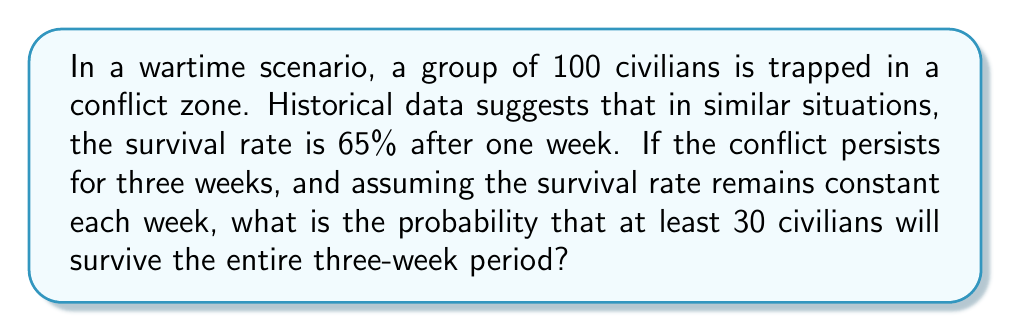Show me your answer to this math problem. Let's approach this problem step-by-step:

1) First, we need to calculate the probability of survival for the entire three-week period. If the weekly survival rate is 65%, then:

   $P(\text{survival for 3 weeks}) = 0.65 \times 0.65 \times 0.65 = 0.65^3 \approx 0.2746$

2) Now, we can consider this as a binomial probability problem. We want to find the probability of at least 30 successes (survivors) out of 100 trials, where the probability of success on each trial is 0.2746.

3) The probability of at least 30 survivors is equal to 1 minus the probability of 29 or fewer survivors:

   $P(X \geq 30) = 1 - P(X \leq 29)$

   where X is the number of survivors.

4) We can calculate this using the cumulative binomial probability function:

   $P(X \geq 30) = 1 - \sum_{k=0}^{29} \binom{100}{k} p^k (1-p)^{100-k}$

   where $p = 0.2746$

5) This sum is complex to calculate by hand, so we would typically use statistical software or a calculator with a binomial cumulative distribution function.

6) Using such a tool, we find:

   $P(X \geq 30) \approx 0.9999$

This means the probability of at least 30 civilians surviving the three-week period is approximately 99.99%.
Answer: $P(X \geq 30) \approx 0.9999$ or approximately 99.99% 